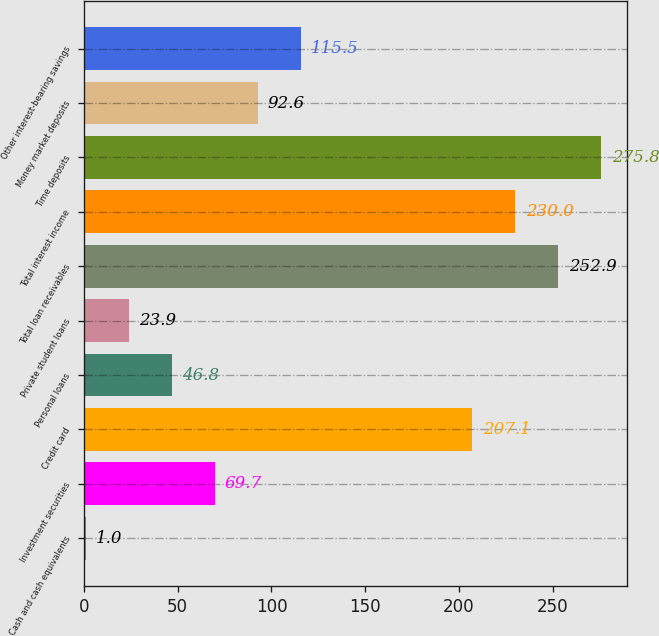Convert chart to OTSL. <chart><loc_0><loc_0><loc_500><loc_500><bar_chart><fcel>Cash and cash equivalents<fcel>Investment securities<fcel>Credit card<fcel>Personal loans<fcel>Private student loans<fcel>Total loan receivables<fcel>Total interest income<fcel>Time deposits<fcel>Money market deposits<fcel>Other interest-bearing savings<nl><fcel>1<fcel>69.7<fcel>207.1<fcel>46.8<fcel>23.9<fcel>252.9<fcel>230<fcel>275.8<fcel>92.6<fcel>115.5<nl></chart> 